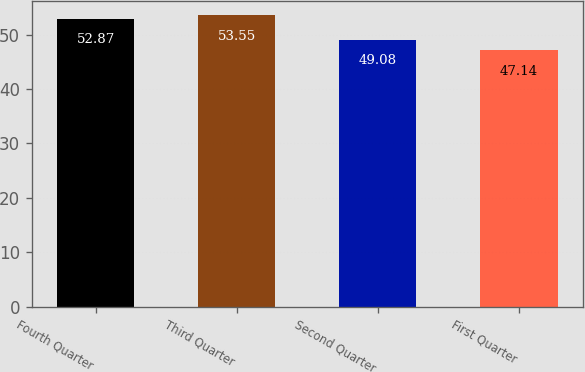Convert chart. <chart><loc_0><loc_0><loc_500><loc_500><bar_chart><fcel>Fourth Quarter<fcel>Third Quarter<fcel>Second Quarter<fcel>First Quarter<nl><fcel>52.87<fcel>53.55<fcel>49.08<fcel>47.14<nl></chart> 